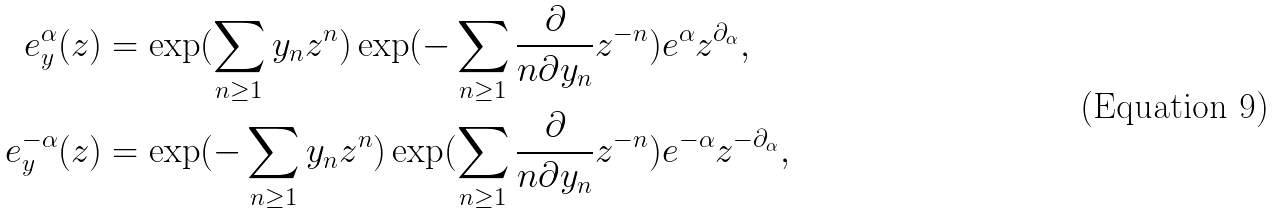Convert formula to latex. <formula><loc_0><loc_0><loc_500><loc_500>e ^ { \alpha } _ { y } ( z ) & = \exp ( \sum _ { n \geq 1 } y _ { n } z ^ { n } ) \exp ( - \sum _ { n \geq 1 } \frac { \partial } { n \partial y _ { n } } z ^ { - n } ) e ^ { \alpha } z ^ { \partial _ { \alpha } } , \\ e ^ { - \alpha } _ { y } ( z ) & = \exp ( - \sum _ { n \geq 1 } y _ { n } z ^ { n } ) \exp ( \sum _ { n \geq 1 } \frac { \partial } { n \partial y _ { n } } z ^ { - n } ) e ^ { - \alpha } z ^ { - \partial _ { \alpha } } ,</formula> 